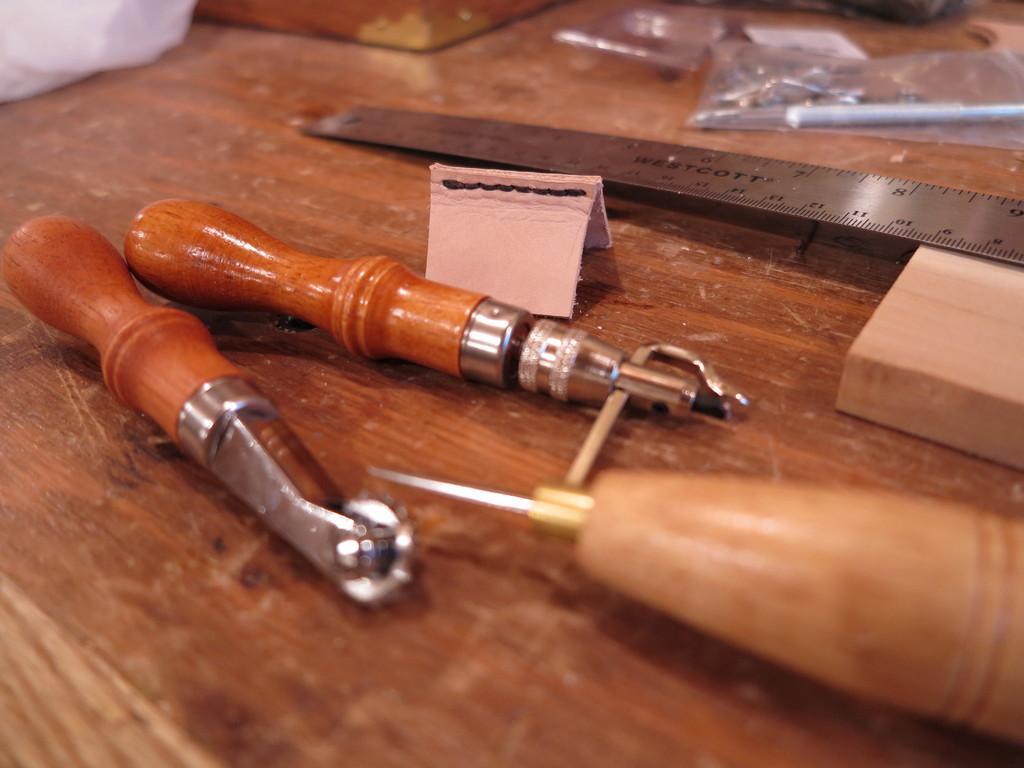How would you summarize this image in a sentence or two? In this image I can see brown colour surface and on it I can see few tools, an iron scale and few other things. I can also see this image is little bit blurry from background. 